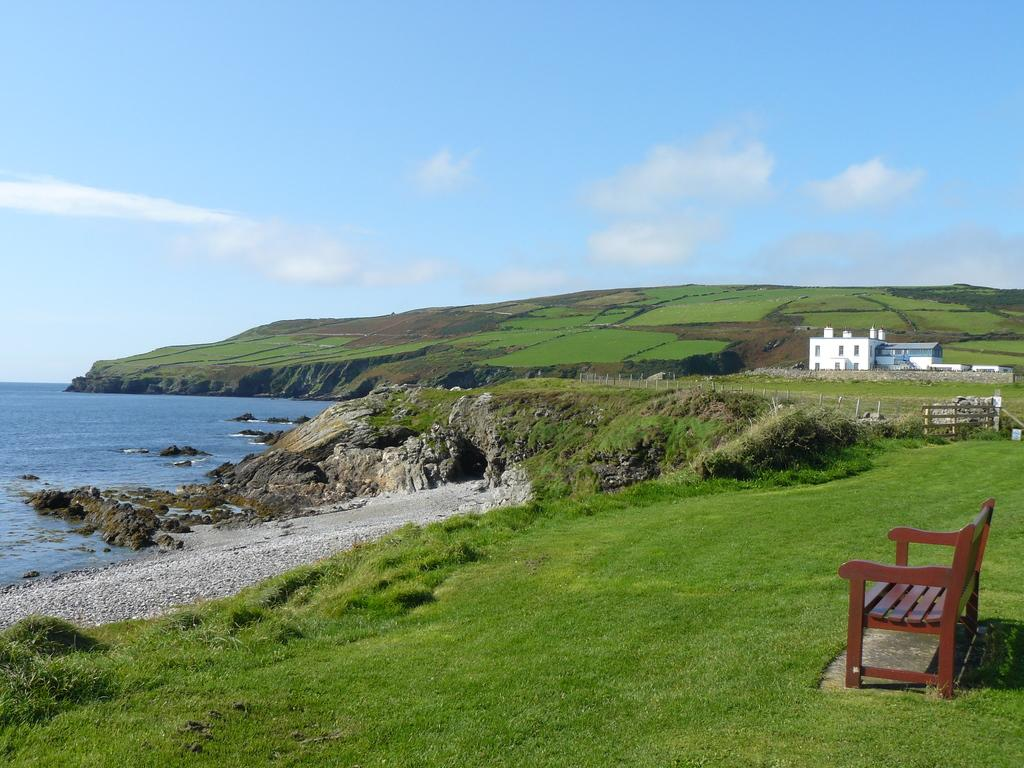What type of seating is visible in the image? There is a bench in the image. What type of structure can be seen in the image? There is a house in the image. What type of barrier is present in the image? There is a fence in the image. What type of vegetation is present in the image? There is grass in the image. What type of natural feature is present in the image? There is a hill in the image. What type of body of water is present in the image? There is water in the image. What is visible in the background of the image? The sky is visible in the background of the image. What type of meat is being cooked on the grill in the image? There is no grill or meat present in the image. What type of learning material is visible on the bench in the image? There is no learning material visible on the bench in the image. 